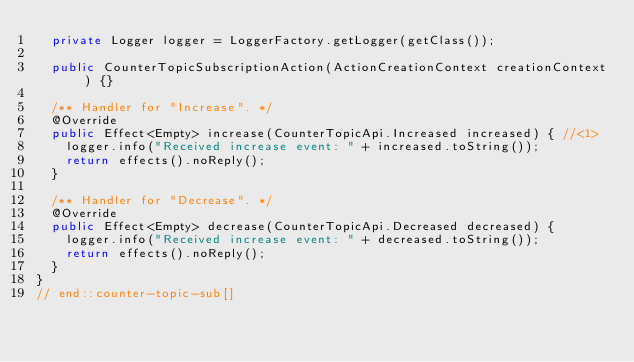<code> <loc_0><loc_0><loc_500><loc_500><_Java_>  private Logger logger = LoggerFactory.getLogger(getClass());

  public CounterTopicSubscriptionAction(ActionCreationContext creationContext) {}

  /** Handler for "Increase". */
  @Override
  public Effect<Empty> increase(CounterTopicApi.Increased increased) { //<1> 
    logger.info("Received increase event: " + increased.toString());
    return effects().noReply();
  }

  /** Handler for "Decrease". */
  @Override
  public Effect<Empty> decrease(CounterTopicApi.Decreased decreased) {  
    logger.info("Received increase event: " + decreased.toString());
    return effects().noReply();
  }
}
// end::counter-topic-sub[]</code> 